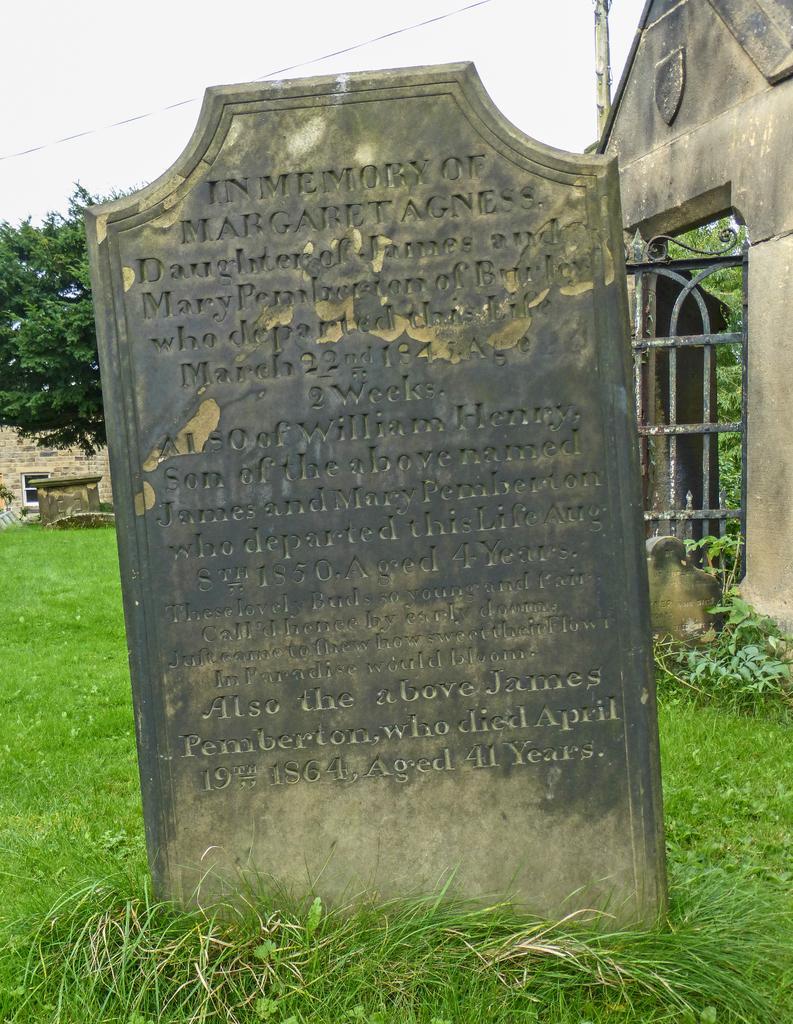Could you give a brief overview of what you see in this image? In this picture there is a stone and there is text on the stone. At the back there are buildings and trees and there is a pole. At the top there is sky and there is a wire. At the bottom there are plants and there is grass. 